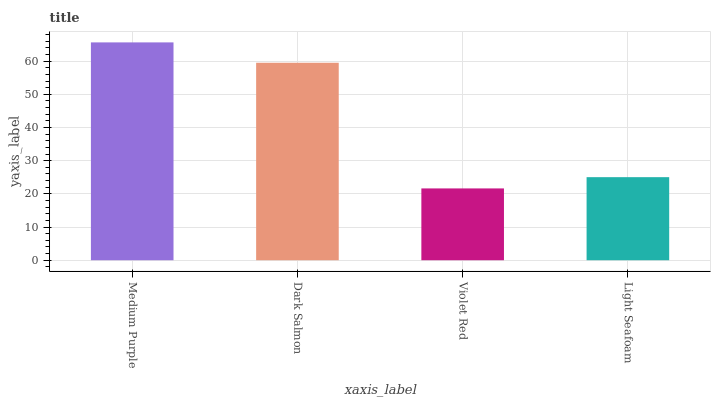Is Violet Red the minimum?
Answer yes or no. Yes. Is Medium Purple the maximum?
Answer yes or no. Yes. Is Dark Salmon the minimum?
Answer yes or no. No. Is Dark Salmon the maximum?
Answer yes or no. No. Is Medium Purple greater than Dark Salmon?
Answer yes or no. Yes. Is Dark Salmon less than Medium Purple?
Answer yes or no. Yes. Is Dark Salmon greater than Medium Purple?
Answer yes or no. No. Is Medium Purple less than Dark Salmon?
Answer yes or no. No. Is Dark Salmon the high median?
Answer yes or no. Yes. Is Light Seafoam the low median?
Answer yes or no. Yes. Is Violet Red the high median?
Answer yes or no. No. Is Medium Purple the low median?
Answer yes or no. No. 